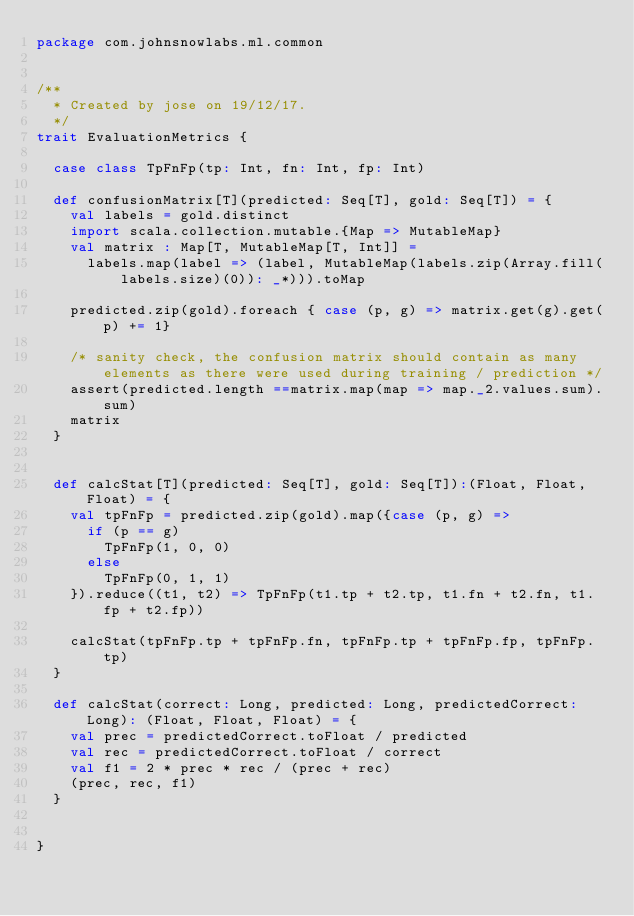Convert code to text. <code><loc_0><loc_0><loc_500><loc_500><_Scala_>package com.johnsnowlabs.ml.common


/**
  * Created by jose on 19/12/17.
  */
trait EvaluationMetrics {

  case class TpFnFp(tp: Int, fn: Int, fp: Int)

  def confusionMatrix[T](predicted: Seq[T], gold: Seq[T]) = {
    val labels = gold.distinct
    import scala.collection.mutable.{Map => MutableMap}
    val matrix : Map[T, MutableMap[T, Int]] =
      labels.map(label => (label, MutableMap(labels.zip(Array.fill(labels.size)(0)): _*))).toMap

    predicted.zip(gold).foreach { case (p, g) => matrix.get(g).get(p) += 1}

    /* sanity check, the confusion matrix should contain as many elements as there were used during training / prediction */
    assert(predicted.length ==matrix.map(map => map._2.values.sum).sum)
    matrix
  }


  def calcStat[T](predicted: Seq[T], gold: Seq[T]):(Float, Float, Float) = {
    val tpFnFp = predicted.zip(gold).map({case (p, g) =>
      if (p == g)
        TpFnFp(1, 0, 0)
      else
        TpFnFp(0, 1, 1)
    }).reduce((t1, t2) => TpFnFp(t1.tp + t2.tp, t1.fn + t2.fn, t1.fp + t2.fp))

    calcStat(tpFnFp.tp + tpFnFp.fn, tpFnFp.tp + tpFnFp.fp, tpFnFp.tp)
  }

  def calcStat(correct: Long, predicted: Long, predictedCorrect: Long): (Float, Float, Float) = {
    val prec = predictedCorrect.toFloat / predicted
    val rec = predictedCorrect.toFloat / correct
    val f1 = 2 * prec * rec / (prec + rec)
    (prec, rec, f1)
  }


}
</code> 